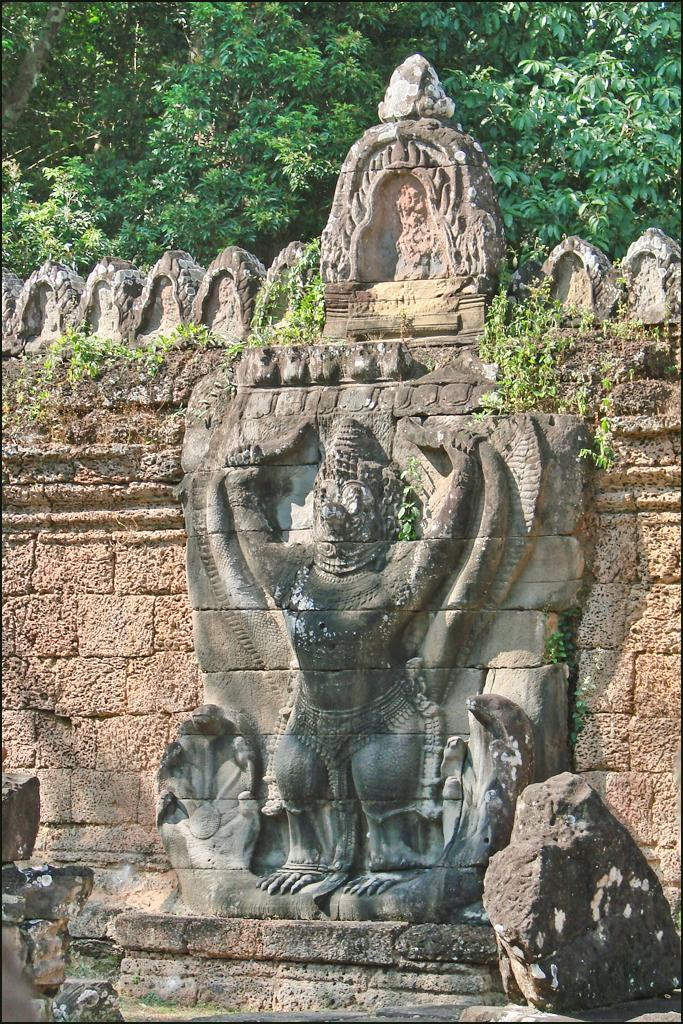What is on the wall in the image? There is a sculpture on the wall in the image. What is located at the bottom of the image? There is a stone at the bottom of the image. What type of vegetation can be seen in the image? Plants are visible in the image. What is present at the top of the image? Trees are present at the top of the image. How many beads are scattered around the stone in the image? There are no beads present in the image; it only features a sculpture, a stone, plants, and trees. Is there a person walking near the trees in the image? There is no person present in the image; it only features a sculpture, a stone, plants, and trees. 